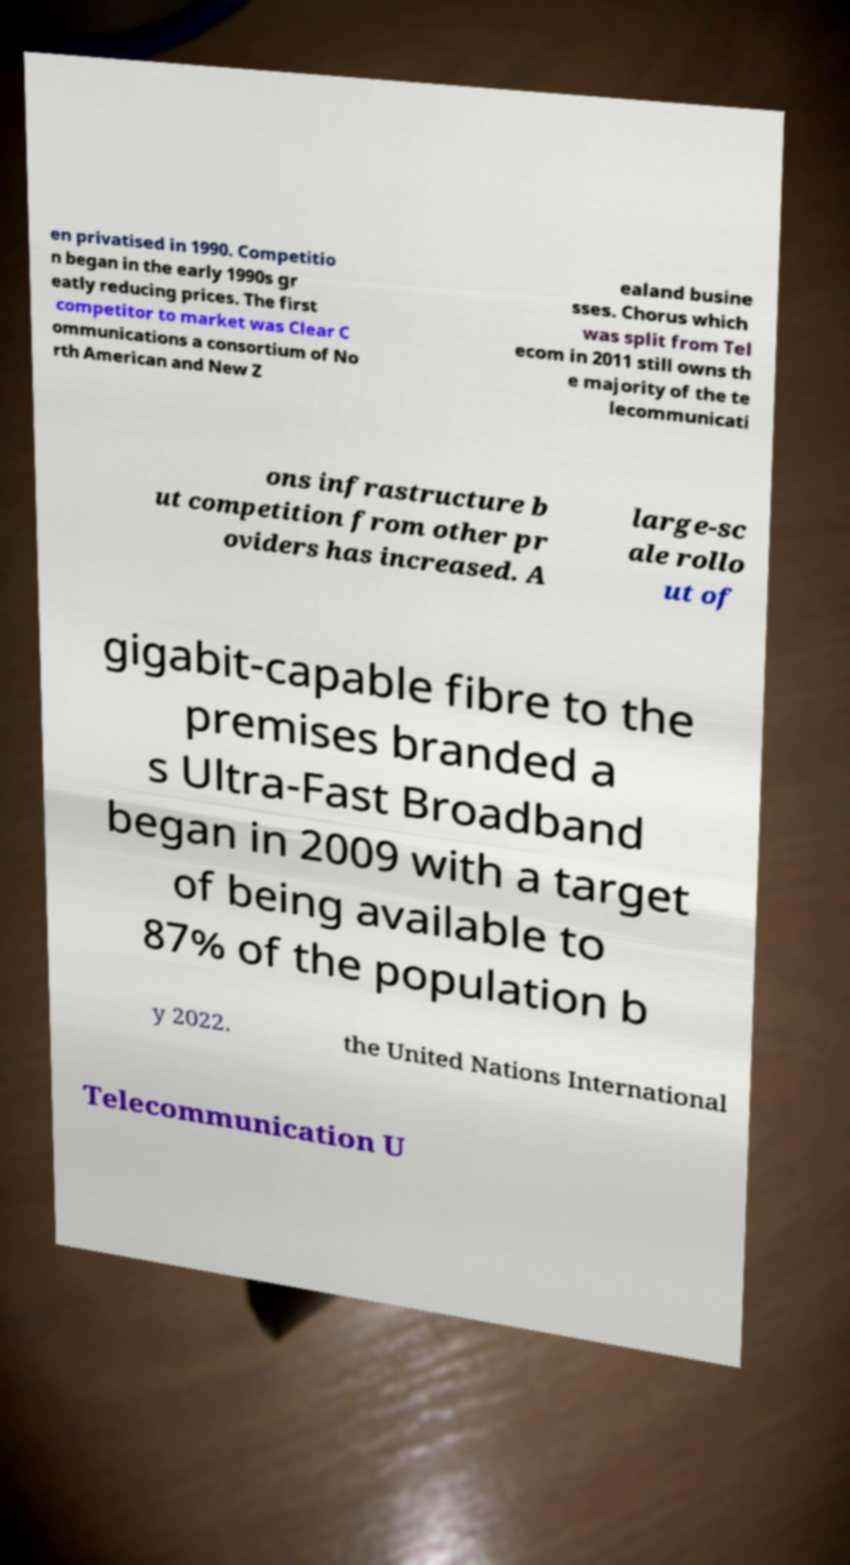Please identify and transcribe the text found in this image. en privatised in 1990. Competitio n began in the early 1990s gr eatly reducing prices. The first competitor to market was Clear C ommunications a consortium of No rth American and New Z ealand busine sses. Chorus which was split from Tel ecom in 2011 still owns th e majority of the te lecommunicati ons infrastructure b ut competition from other pr oviders has increased. A large-sc ale rollo ut of gigabit-capable fibre to the premises branded a s Ultra-Fast Broadband began in 2009 with a target of being available to 87% of the population b y 2022. the United Nations International Telecommunication U 